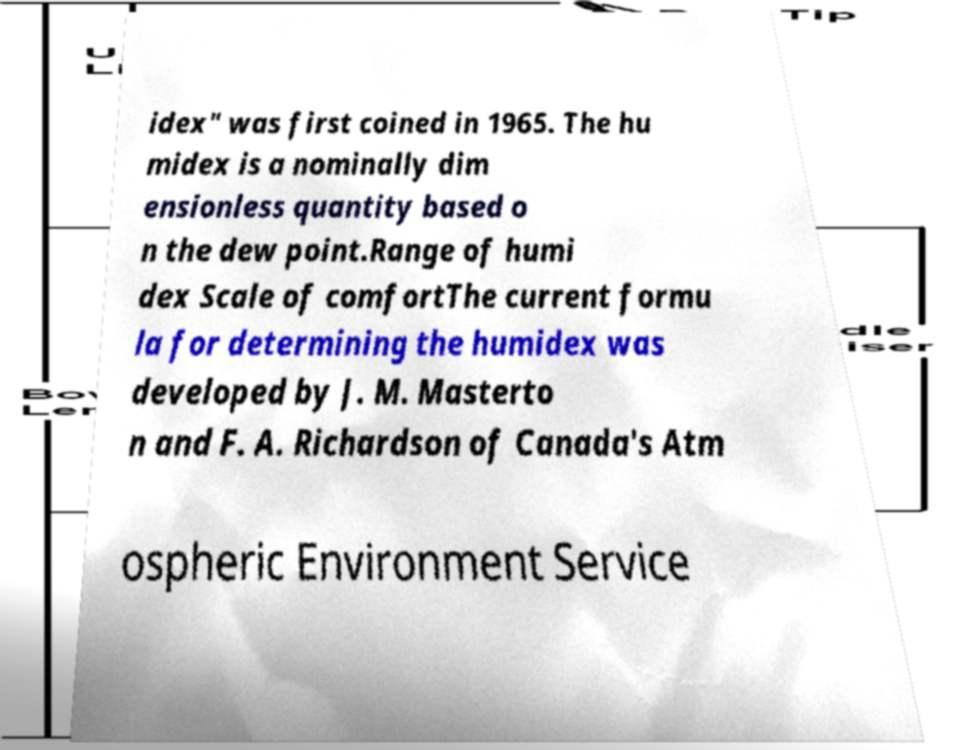Can you accurately transcribe the text from the provided image for me? idex" was first coined in 1965. The hu midex is a nominally dim ensionless quantity based o n the dew point.Range of humi dex Scale of comfortThe current formu la for determining the humidex was developed by J. M. Masterto n and F. A. Richardson of Canada's Atm ospheric Environment Service 